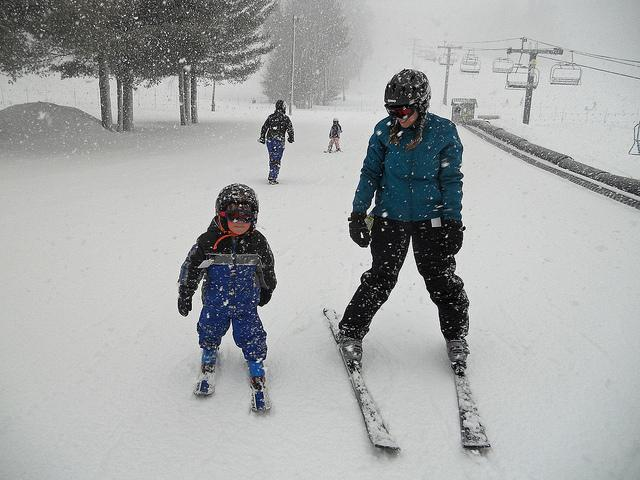What is the contraption on the right used for?

Choices:
A) climbing slopes
B) descending slopes
C) shoveling snow
D) creating snow climbing slopes 